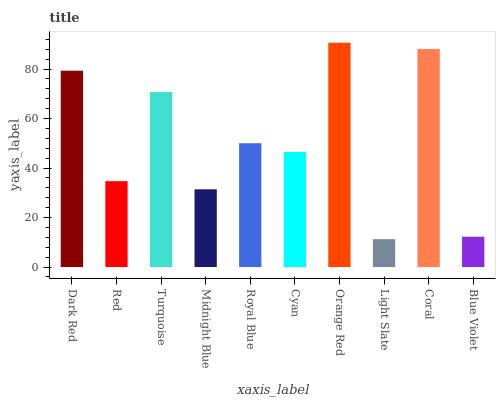Is Light Slate the minimum?
Answer yes or no. Yes. Is Orange Red the maximum?
Answer yes or no. Yes. Is Red the minimum?
Answer yes or no. No. Is Red the maximum?
Answer yes or no. No. Is Dark Red greater than Red?
Answer yes or no. Yes. Is Red less than Dark Red?
Answer yes or no. Yes. Is Red greater than Dark Red?
Answer yes or no. No. Is Dark Red less than Red?
Answer yes or no. No. Is Royal Blue the high median?
Answer yes or no. Yes. Is Cyan the low median?
Answer yes or no. Yes. Is Red the high median?
Answer yes or no. No. Is Red the low median?
Answer yes or no. No. 